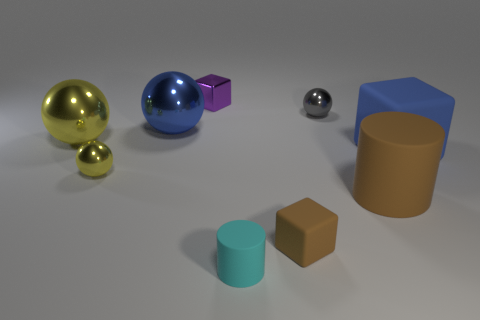What color is the other small metallic object that is the same shape as the tiny yellow object?
Offer a very short reply. Gray. What size is the cyan matte thing?
Provide a succinct answer. Small. How many other brown matte blocks are the same size as the brown matte cube?
Your answer should be compact. 0. Is the color of the tiny cylinder the same as the tiny metallic block?
Your answer should be very brief. No. Does the big blue thing left of the large blue rubber cube have the same material as the yellow ball in front of the big yellow metal object?
Ensure brevity in your answer.  Yes. Is the number of tiny cyan things greater than the number of small metal spheres?
Ensure brevity in your answer.  No. Is there any other thing that is the same color as the large matte cylinder?
Provide a short and direct response. Yes. Are the gray ball and the large blue ball made of the same material?
Provide a short and direct response. Yes. Are there fewer cyan rubber cylinders than objects?
Your answer should be very brief. Yes. Is the small brown object the same shape as the large blue shiny thing?
Provide a succinct answer. No. 